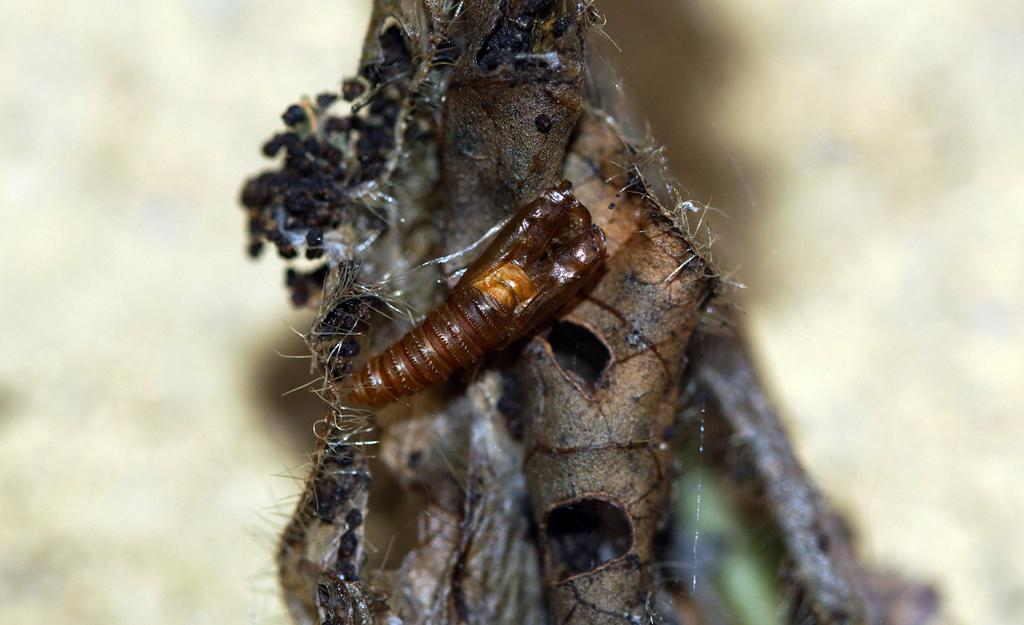What type of creatures can be seen in the image? There are insects in the image. What are the insects located on? The insects are on something, but the specific object is not mentioned in the facts. Can you describe the background of the image? The background of the image is blurred. What type of dirt can be seen on the insects' apparel in the image? There is no mention of dirt or apparel in the image, as it only features insects and a blurred background. 